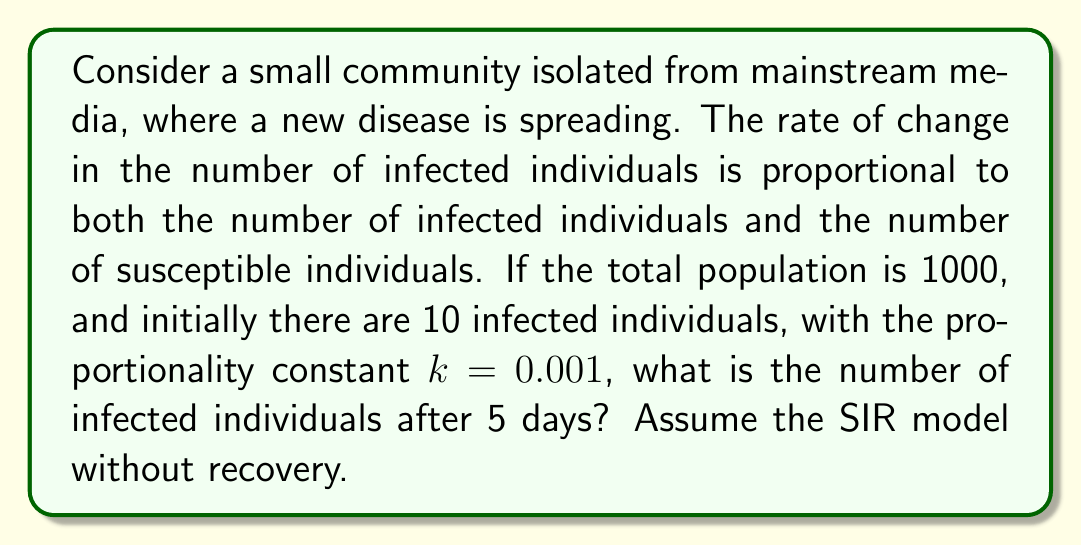Teach me how to tackle this problem. Let's approach this step-by-step using the SIR model without recovery:

1) Let $I(t)$ be the number of infected individuals at time $t$.

2) The differential equation for this model is:

   $$\frac{dI}{dt} = kI(N-I)$$

   where $N$ is the total population and $k$ is the proportionality constant.

3) This is a logistic equation. Its solution is:

   $$I(t) = \frac{N}{1 + (\frac{N}{I_0} - 1)e^{-kNt}}$$

   where $I_0$ is the initial number of infected individuals.

4) We are given:
   $N = 1000$
   $I_0 = 10$
   $k = 0.001$
   $t = 5$ (days)

5) Substituting these values into the equation:

   $$I(5) = \frac{1000}{1 + (\frac{1000}{10} - 1)e^{-0.001 \cdot 1000 \cdot 5}}$$

6) Simplify:
   $$I(5) = \frac{1000}{1 + 99e^{-5}}$$

7) Calculate:
   $$I(5) \approx 54.96$$

8) Since we're dealing with individuals, we round to the nearest whole number.
Answer: 55 infected individuals 